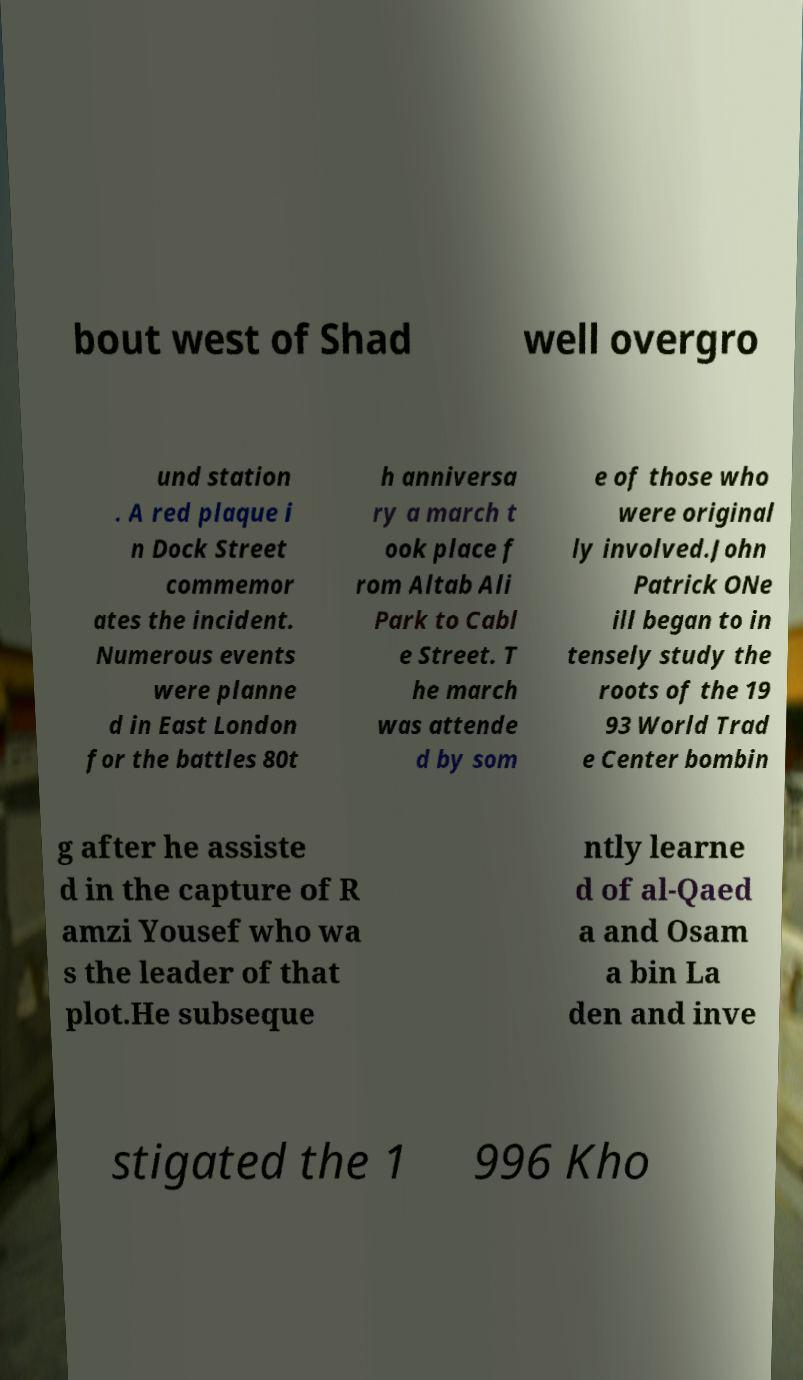Can you accurately transcribe the text from the provided image for me? bout west of Shad well overgro und station . A red plaque i n Dock Street commemor ates the incident. Numerous events were planne d in East London for the battles 80t h anniversa ry a march t ook place f rom Altab Ali Park to Cabl e Street. T he march was attende d by som e of those who were original ly involved.John Patrick ONe ill began to in tensely study the roots of the 19 93 World Trad e Center bombin g after he assiste d in the capture of R amzi Yousef who wa s the leader of that plot.He subseque ntly learne d of al-Qaed a and Osam a bin La den and inve stigated the 1 996 Kho 